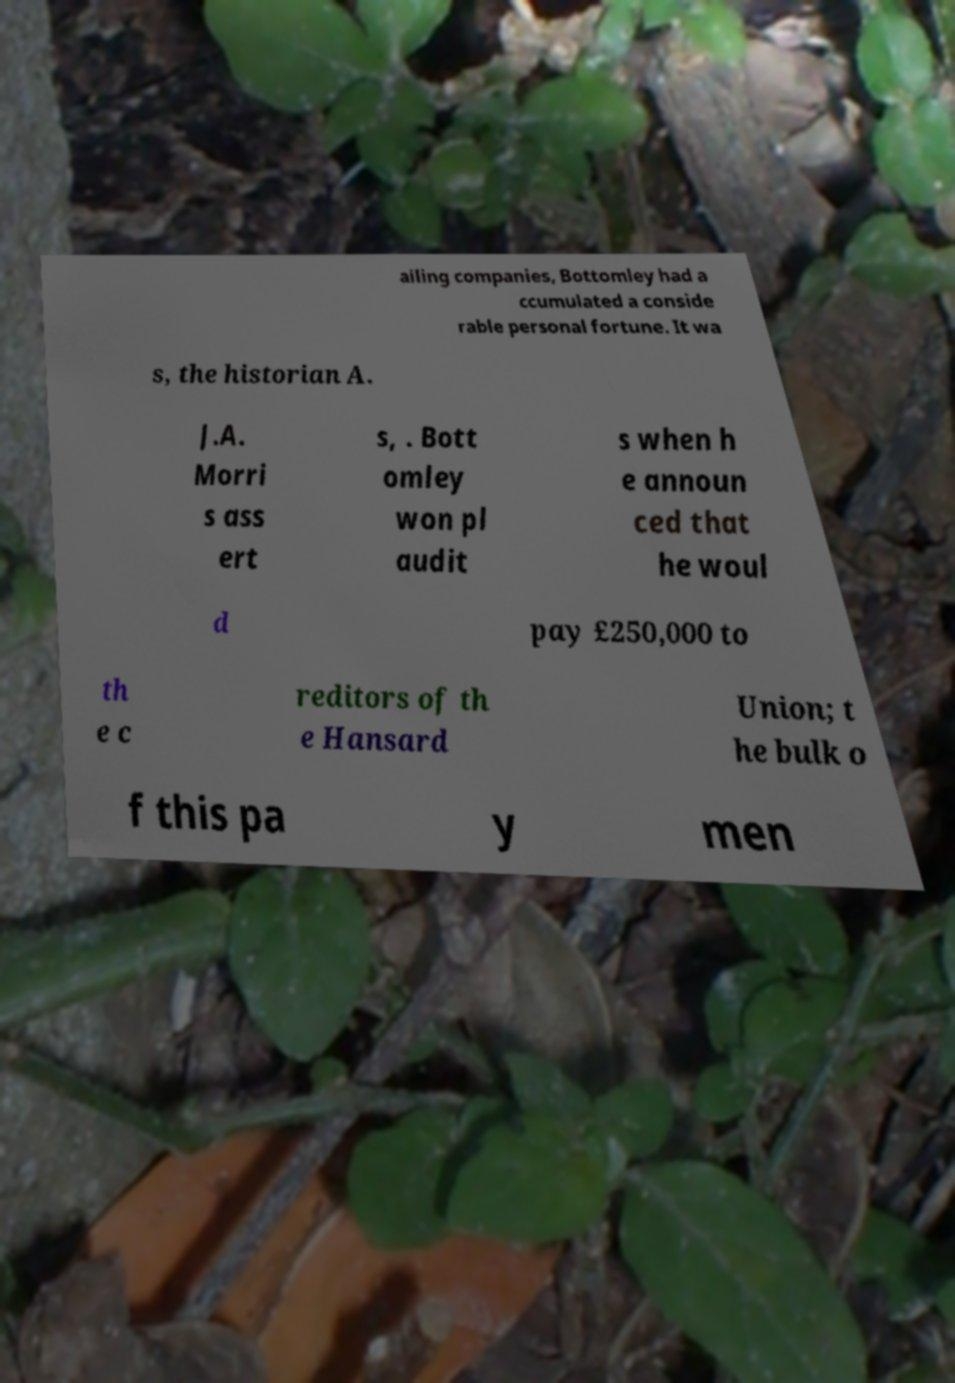Could you extract and type out the text from this image? ailing companies, Bottomley had a ccumulated a conside rable personal fortune. It wa s, the historian A. J.A. Morri s ass ert s, . Bott omley won pl audit s when h e announ ced that he woul d pay £250,000 to th e c reditors of th e Hansard Union; t he bulk o f this pa y men 